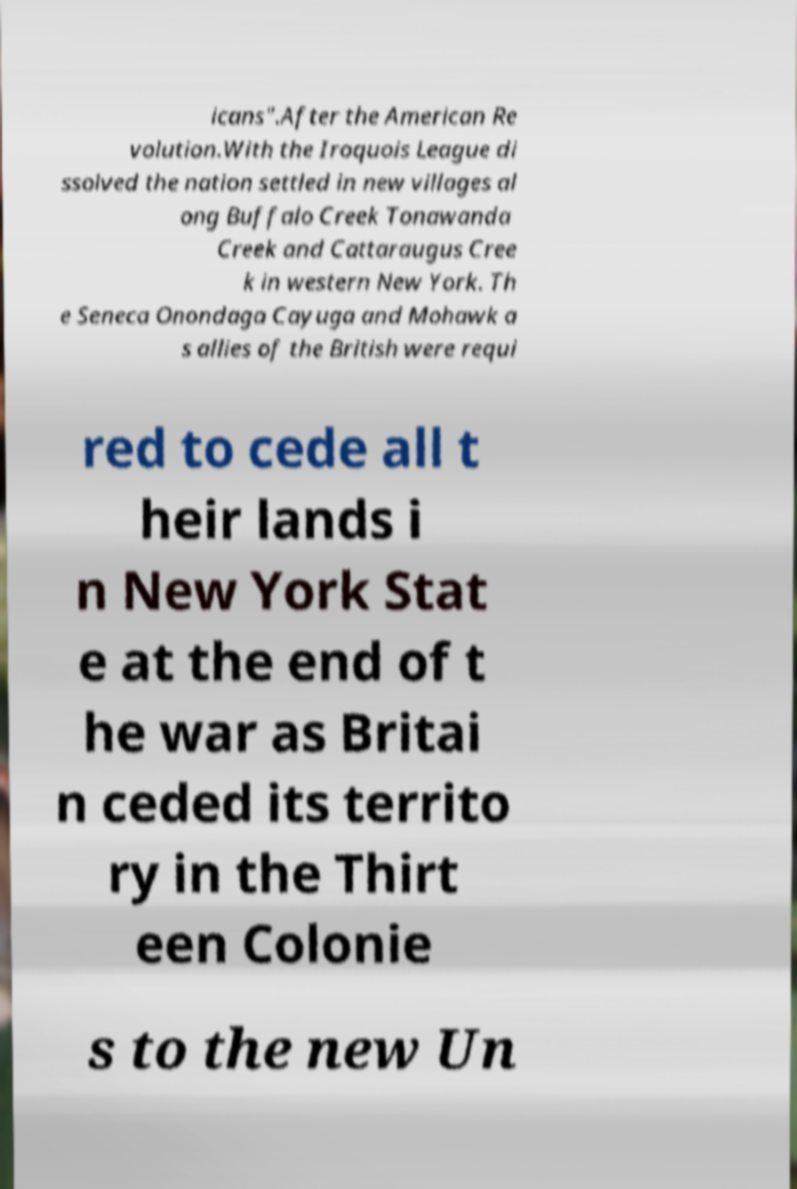What messages or text are displayed in this image? I need them in a readable, typed format. icans".After the American Re volution.With the Iroquois League di ssolved the nation settled in new villages al ong Buffalo Creek Tonawanda Creek and Cattaraugus Cree k in western New York. Th e Seneca Onondaga Cayuga and Mohawk a s allies of the British were requi red to cede all t heir lands i n New York Stat e at the end of t he war as Britai n ceded its territo ry in the Thirt een Colonie s to the new Un 